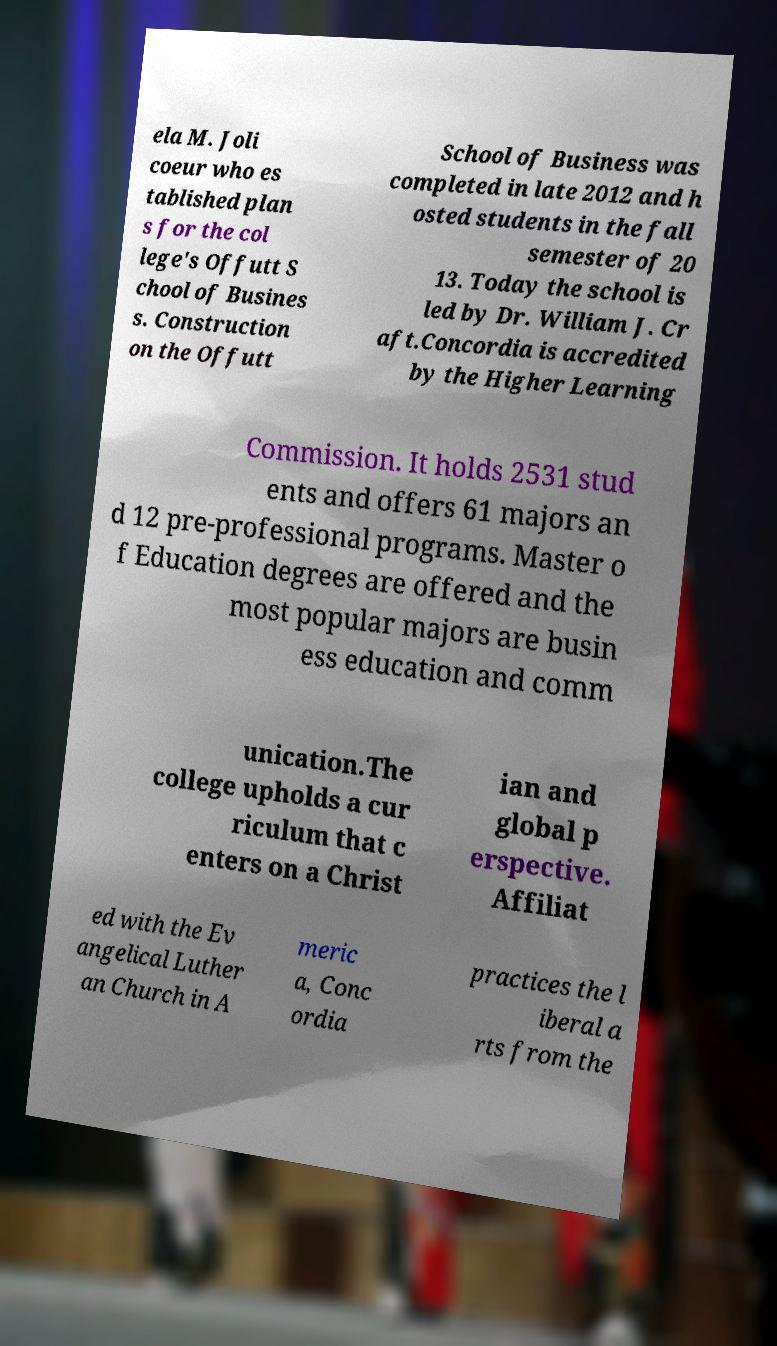I need the written content from this picture converted into text. Can you do that? ela M. Joli coeur who es tablished plan s for the col lege's Offutt S chool of Busines s. Construction on the Offutt School of Business was completed in late 2012 and h osted students in the fall semester of 20 13. Today the school is led by Dr. William J. Cr aft.Concordia is accredited by the Higher Learning Commission. It holds 2531 stud ents and offers 61 majors an d 12 pre-professional programs. Master o f Education degrees are offered and the most popular majors are busin ess education and comm unication.The college upholds a cur riculum that c enters on a Christ ian and global p erspective. Affiliat ed with the Ev angelical Luther an Church in A meric a, Conc ordia practices the l iberal a rts from the 